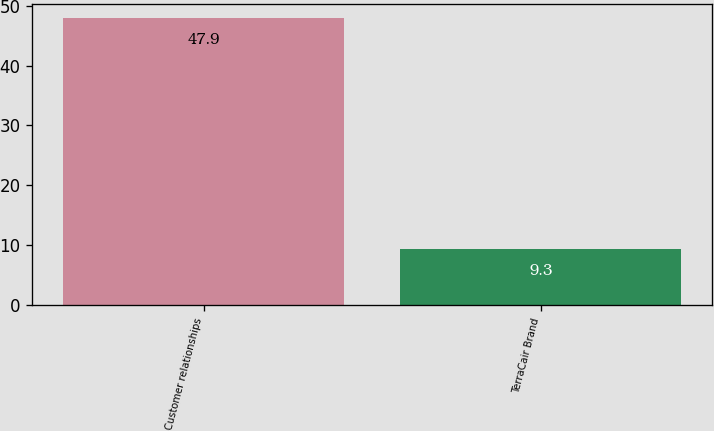Convert chart. <chart><loc_0><loc_0><loc_500><loc_500><bar_chart><fcel>Customer relationships<fcel>TerraCair Brand<nl><fcel>47.9<fcel>9.3<nl></chart> 